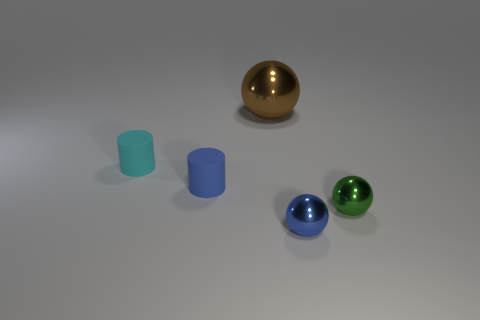Is the shape of the large metallic thing that is right of the cyan rubber object the same as  the cyan object?
Your answer should be very brief. No. The other object that is the same shape as the cyan matte object is what color?
Keep it short and to the point. Blue. Are there any other things that have the same shape as the cyan object?
Ensure brevity in your answer.  Yes. Are there an equal number of tiny cylinders that are right of the big brown object and yellow metallic things?
Provide a succinct answer. Yes. How many shiny objects are in front of the big brown shiny ball and to the left of the small green metal thing?
Give a very brief answer. 1. There is another green metallic object that is the same shape as the big thing; what size is it?
Offer a very short reply. Small. How many tiny blue things are made of the same material as the big brown thing?
Provide a succinct answer. 1. Is the number of brown things behind the blue metal sphere less than the number of tiny yellow cubes?
Provide a succinct answer. No. What number of big brown objects are there?
Offer a terse response. 1. What number of small metallic objects are the same color as the large metallic thing?
Make the answer very short. 0. 